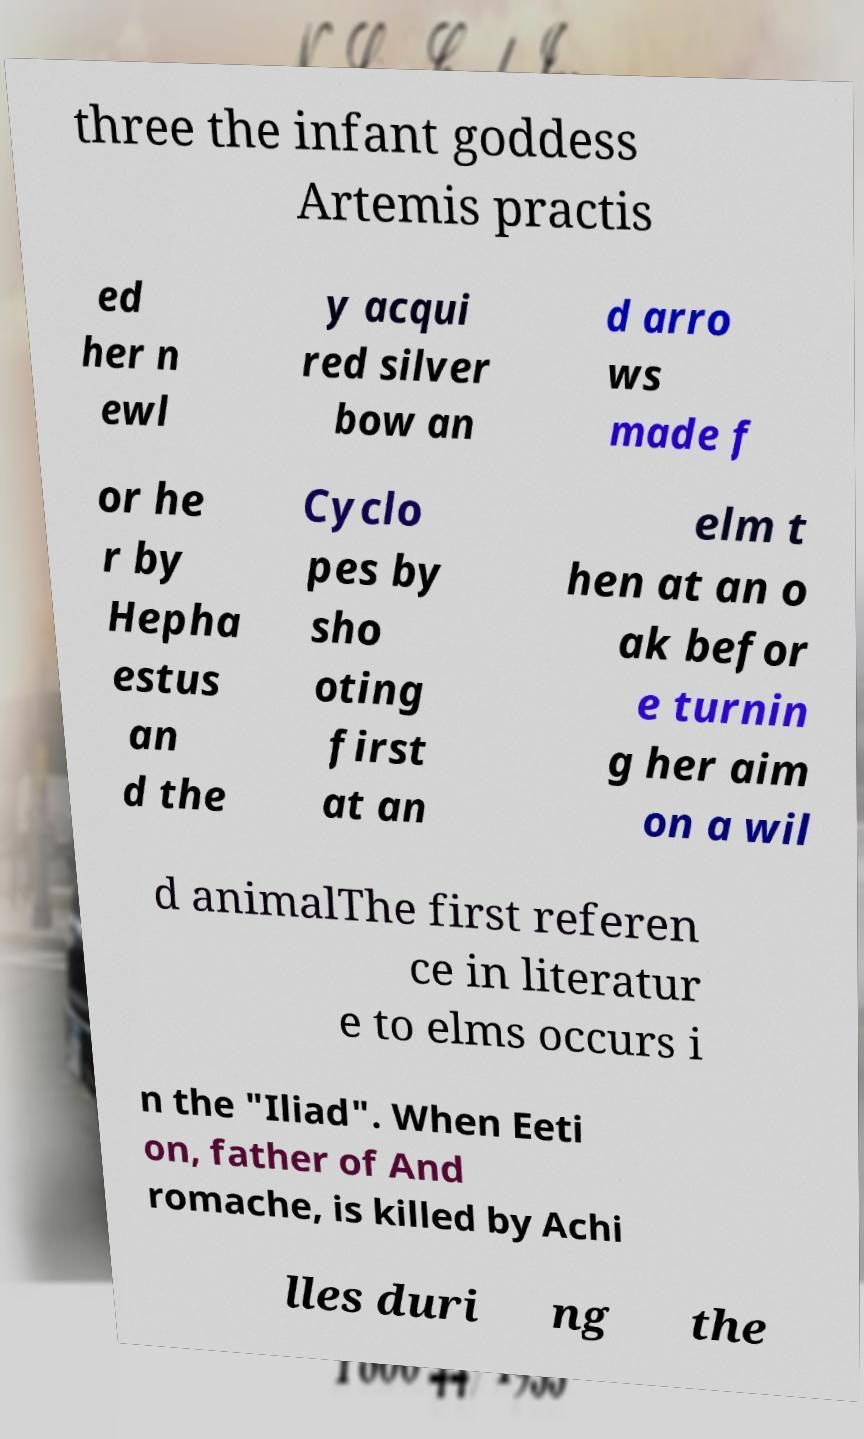Please identify and transcribe the text found in this image. three the infant goddess Artemis practis ed her n ewl y acqui red silver bow an d arro ws made f or he r by Hepha estus an d the Cyclo pes by sho oting first at an elm t hen at an o ak befor e turnin g her aim on a wil d animalThe first referen ce in literatur e to elms occurs i n the "Iliad". When Eeti on, father of And romache, is killed by Achi lles duri ng the 